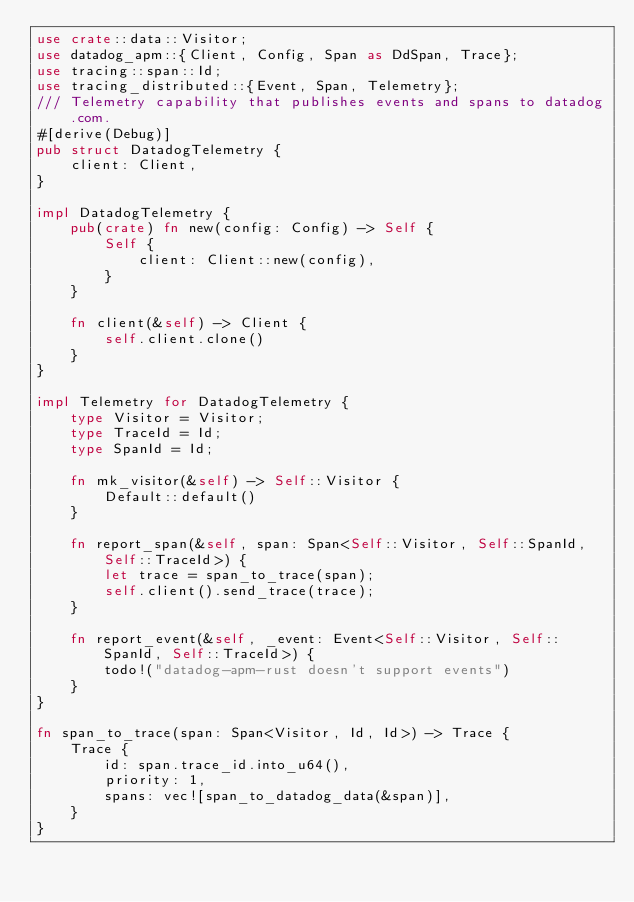<code> <loc_0><loc_0><loc_500><loc_500><_Rust_>use crate::data::Visitor;
use datadog_apm::{Client, Config, Span as DdSpan, Trace};
use tracing::span::Id;
use tracing_distributed::{Event, Span, Telemetry};
/// Telemetry capability that publishes events and spans to datadog.com.
#[derive(Debug)]
pub struct DatadogTelemetry {
    client: Client,
}

impl DatadogTelemetry {
    pub(crate) fn new(config: Config) -> Self {
        Self {
            client: Client::new(config),
        }
    }

    fn client(&self) -> Client {
        self.client.clone()
    }
}

impl Telemetry for DatadogTelemetry {
    type Visitor = Visitor;
    type TraceId = Id;
    type SpanId = Id;

    fn mk_visitor(&self) -> Self::Visitor {
        Default::default()
    }

    fn report_span(&self, span: Span<Self::Visitor, Self::SpanId, Self::TraceId>) {
        let trace = span_to_trace(span);
        self.client().send_trace(trace);
    }

    fn report_event(&self, _event: Event<Self::Visitor, Self::SpanId, Self::TraceId>) {
        todo!("datadog-apm-rust doesn't support events")
    }
}

fn span_to_trace(span: Span<Visitor, Id, Id>) -> Trace {
    Trace {
        id: span.trace_id.into_u64(),
        priority: 1,
        spans: vec![span_to_datadog_data(&span)],
    }
}
</code> 